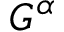Convert formula to latex. <formula><loc_0><loc_0><loc_500><loc_500>G ^ { \alpha }</formula> 